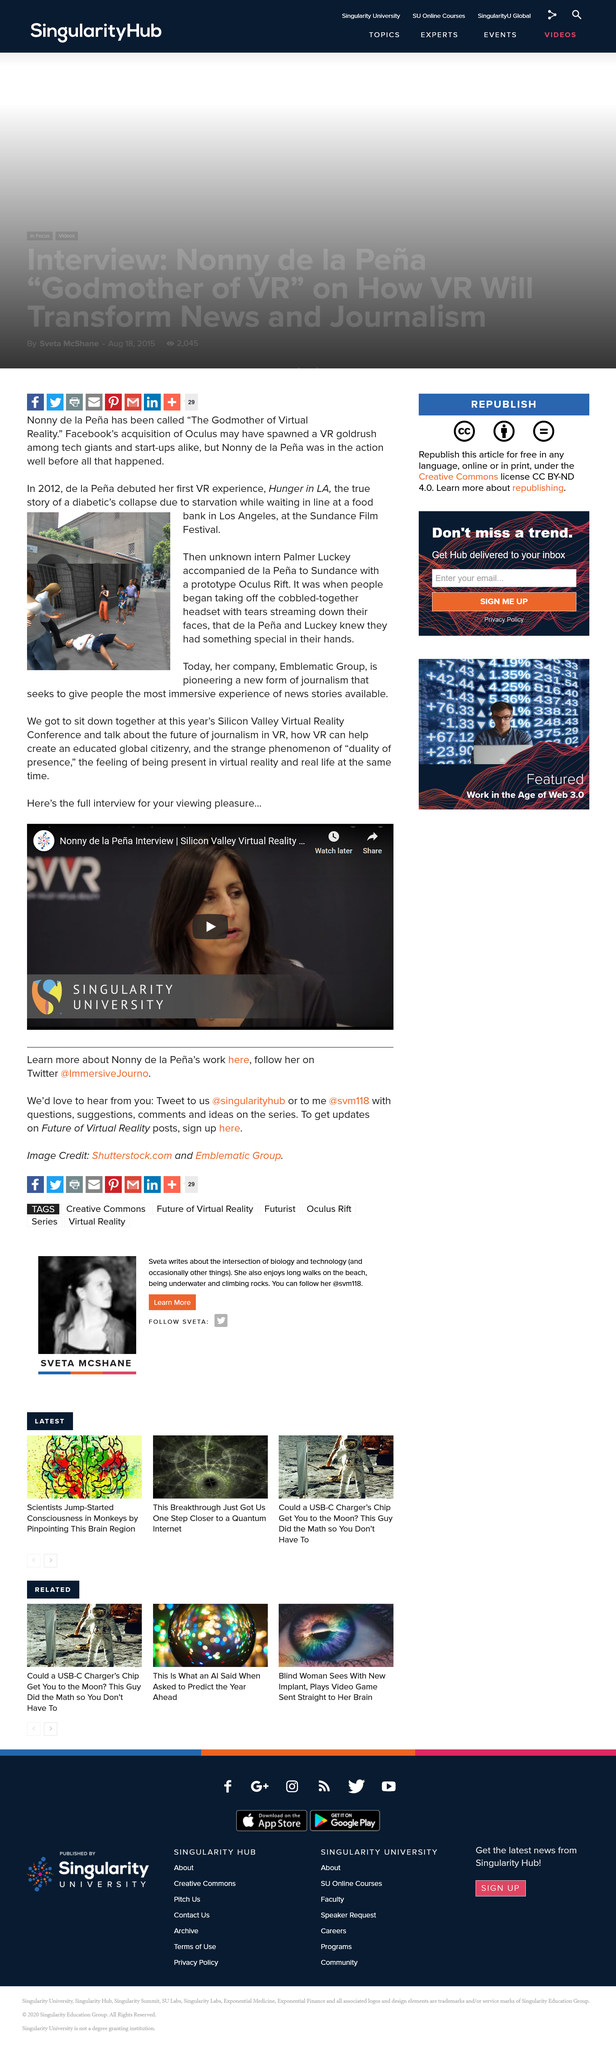Give some essential details in this illustration. Hunger in LA debuted in 2012. Emblematic Group is the name of de la Pena's company. Singularity University is involved with this project, which is being undertaken by a university. The video is about virtual reality technology. The game featured in the photo is "Hunger in LA," which is the focus of the photograph. 